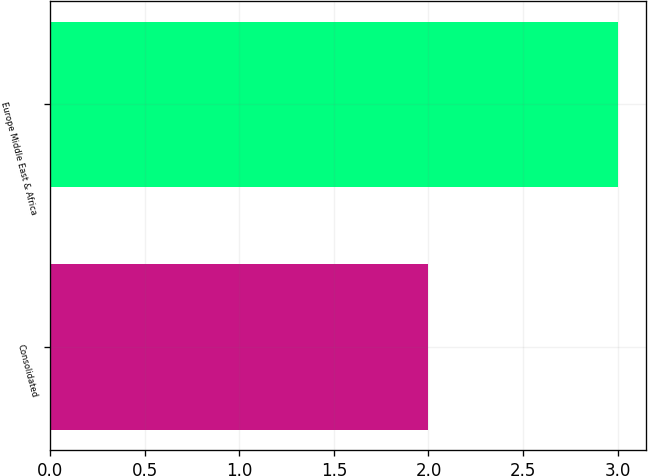<chart> <loc_0><loc_0><loc_500><loc_500><bar_chart><fcel>Consolidated<fcel>Europe Middle East & Africa<nl><fcel>2<fcel>3<nl></chart> 